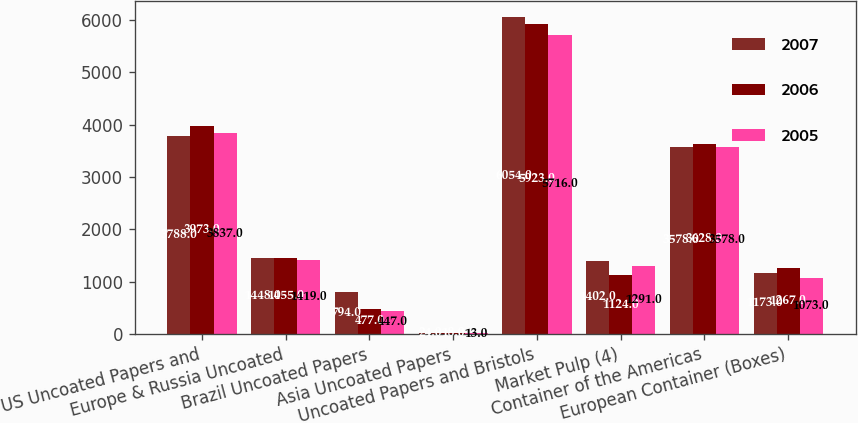Convert chart. <chart><loc_0><loc_0><loc_500><loc_500><stacked_bar_chart><ecel><fcel>US Uncoated Papers and<fcel>Europe & Russia Uncoated<fcel>Brazil Uncoated Papers<fcel>Asia Uncoated Papers<fcel>Uncoated Papers and Bristols<fcel>Market Pulp (4)<fcel>Container of the Americas<fcel>European Container (Boxes)<nl><fcel>2007<fcel>3788<fcel>1448<fcel>794<fcel>24<fcel>6054<fcel>1402<fcel>3578<fcel>1173<nl><fcel>2006<fcel>3973<fcel>1455<fcel>477<fcel>18<fcel>5923<fcel>1124<fcel>3628<fcel>1267<nl><fcel>2005<fcel>3837<fcel>1419<fcel>447<fcel>13<fcel>5716<fcel>1291<fcel>3578<fcel>1073<nl></chart> 